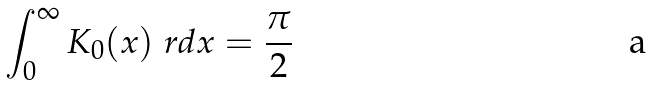<formula> <loc_0><loc_0><loc_500><loc_500>\int _ { 0 } ^ { \infty } K _ { 0 } ( x ) \ r d x = \frac { \pi } { 2 }</formula> 